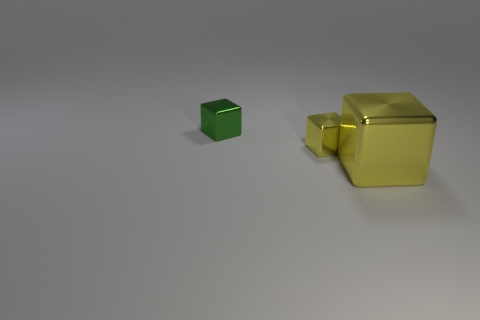Subtract all small metal cubes. How many cubes are left? 1 Add 2 big yellow metal blocks. How many objects exist? 5 Subtract 3 cubes. How many cubes are left? 0 Subtract all green cubes. How many cubes are left? 2 Subtract all red blocks. Subtract all brown cylinders. How many blocks are left? 3 Subtract all cyan spheres. How many green blocks are left? 1 Subtract all shiny cubes. Subtract all large brown metallic cubes. How many objects are left? 0 Add 3 small objects. How many small objects are left? 5 Add 3 big metallic blocks. How many big metallic blocks exist? 4 Subtract 0 yellow cylinders. How many objects are left? 3 